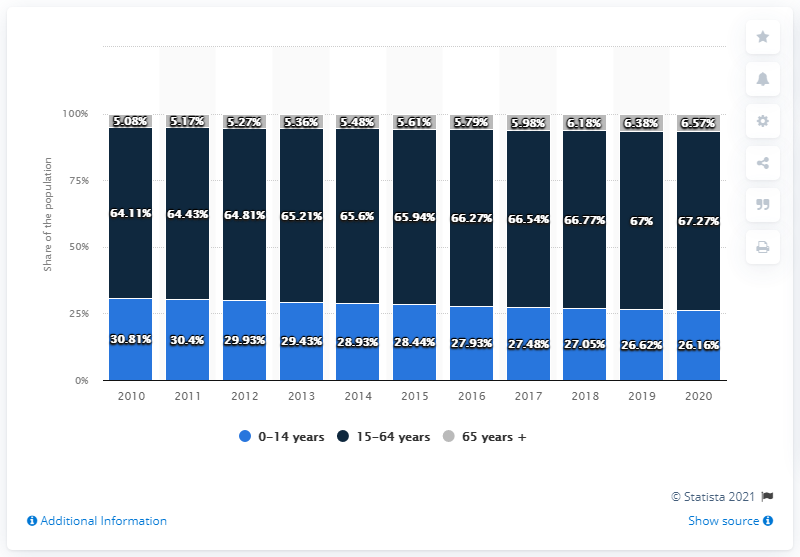Point out several critical features in this image. Yes, the value of the blue bar has decreased over the years. The 15-64 age group and the 65 years and older age group are increasing over time, according to the given data. 